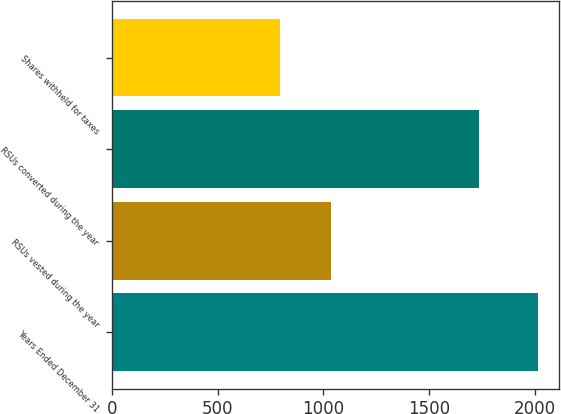Convert chart to OTSL. <chart><loc_0><loc_0><loc_500><loc_500><bar_chart><fcel>Years Ended December 31<fcel>RSUs vested during the year<fcel>RSUs converted during the year<fcel>Shares withheld for taxes<nl><fcel>2014<fcel>1037<fcel>1734<fcel>796<nl></chart> 